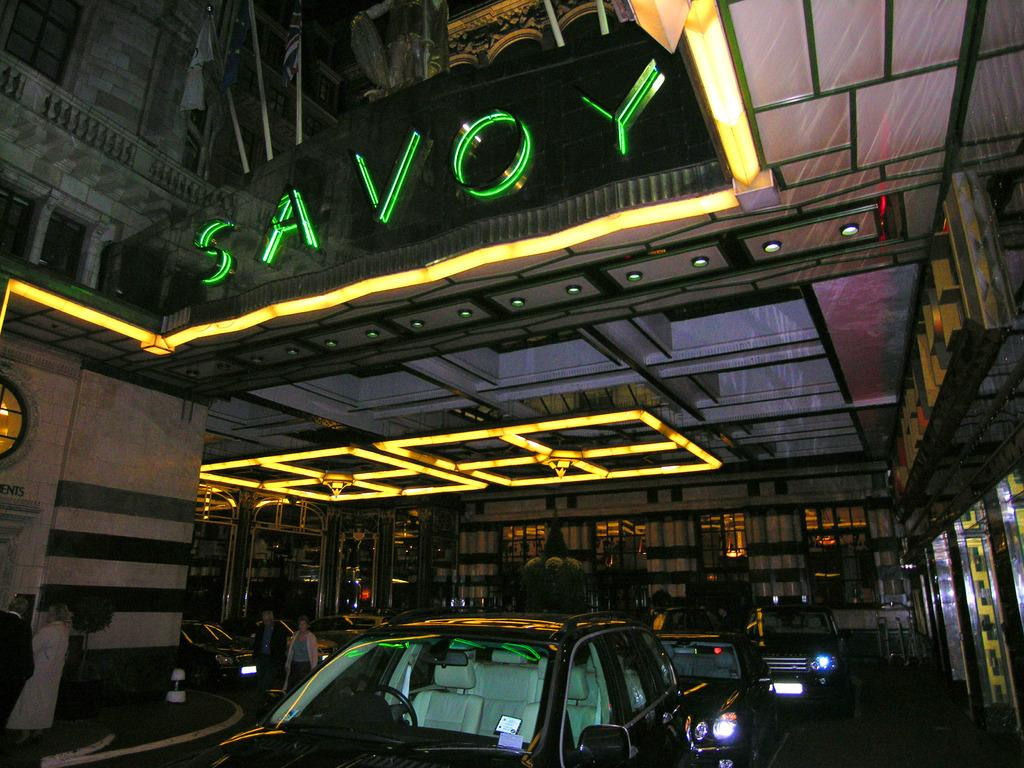<image>
Offer a succinct explanation of the picture presented. Valet parking for guests checking in at the Savoy. 